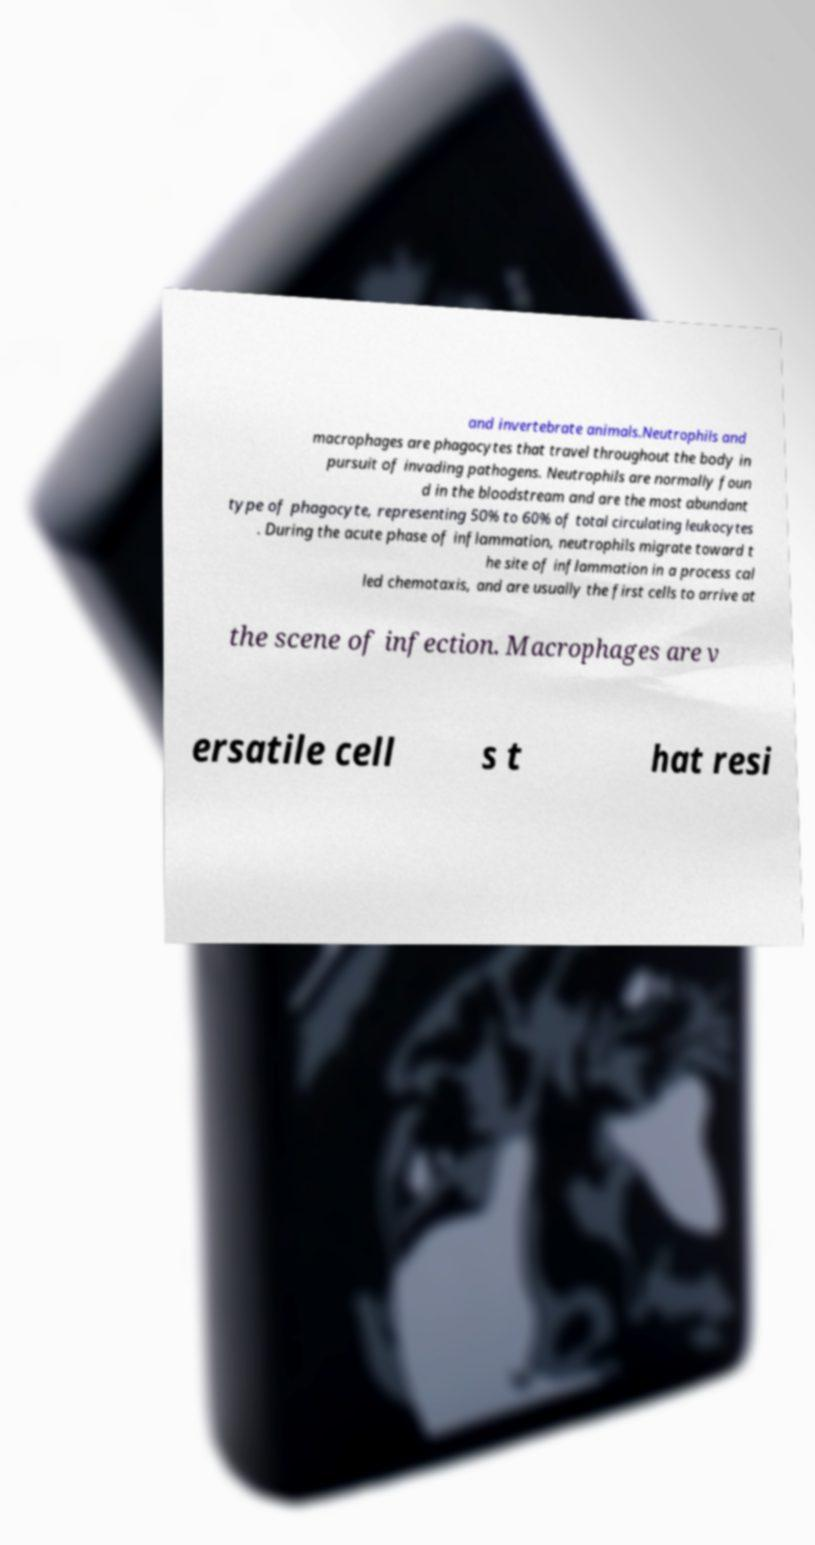Please read and relay the text visible in this image. What does it say? and invertebrate animals.Neutrophils and macrophages are phagocytes that travel throughout the body in pursuit of invading pathogens. Neutrophils are normally foun d in the bloodstream and are the most abundant type of phagocyte, representing 50% to 60% of total circulating leukocytes . During the acute phase of inflammation, neutrophils migrate toward t he site of inflammation in a process cal led chemotaxis, and are usually the first cells to arrive at the scene of infection. Macrophages are v ersatile cell s t hat resi 